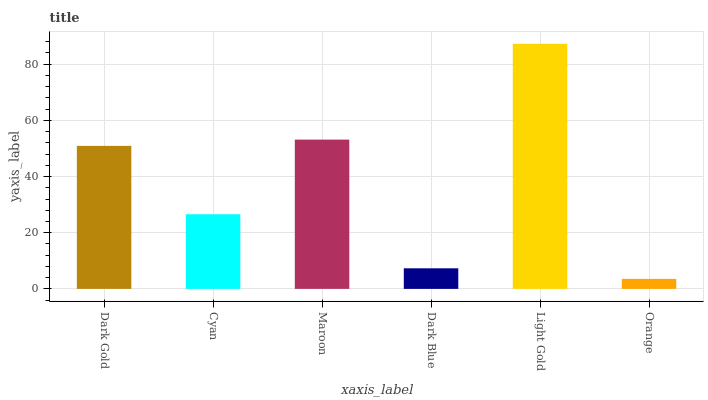Is Orange the minimum?
Answer yes or no. Yes. Is Light Gold the maximum?
Answer yes or no. Yes. Is Cyan the minimum?
Answer yes or no. No. Is Cyan the maximum?
Answer yes or no. No. Is Dark Gold greater than Cyan?
Answer yes or no. Yes. Is Cyan less than Dark Gold?
Answer yes or no. Yes. Is Cyan greater than Dark Gold?
Answer yes or no. No. Is Dark Gold less than Cyan?
Answer yes or no. No. Is Dark Gold the high median?
Answer yes or no. Yes. Is Cyan the low median?
Answer yes or no. Yes. Is Dark Blue the high median?
Answer yes or no. No. Is Maroon the low median?
Answer yes or no. No. 